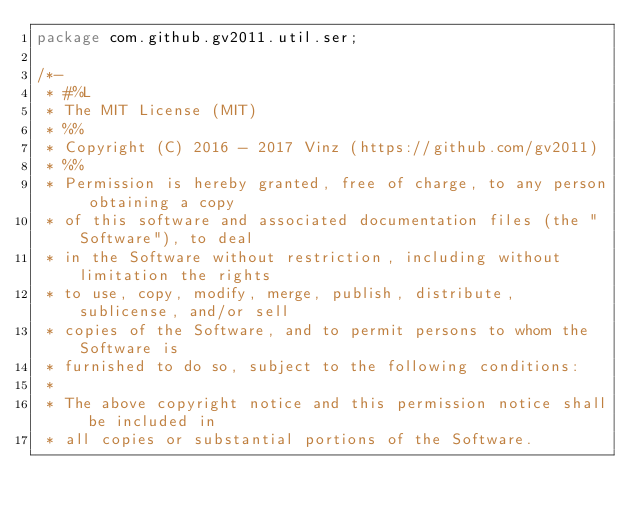Convert code to text. <code><loc_0><loc_0><loc_500><loc_500><_Java_>package com.github.gv2011.util.ser;

/*-
 * #%L
 * The MIT License (MIT)
 * %%
 * Copyright (C) 2016 - 2017 Vinz (https://github.com/gv2011)
 * %%
 * Permission is hereby granted, free of charge, to any person obtaining a copy
 * of this software and associated documentation files (the "Software"), to deal
 * in the Software without restriction, including without limitation the rights
 * to use, copy, modify, merge, publish, distribute, sublicense, and/or sell
 * copies of the Software, and to permit persons to whom the Software is
 * furnished to do so, subject to the following conditions:
 * 
 * The above copyright notice and this permission notice shall be included in
 * all copies or substantial portions of the Software.</code> 